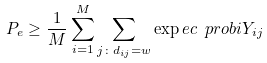Convert formula to latex. <formula><loc_0><loc_0><loc_500><loc_500>P _ { e } \geq \frac { 1 } { M } \sum _ { i = 1 } ^ { M } \sum _ { j \colon d _ { i j } = w } \exp e c { \ p r o b i { Y _ { i j } } }</formula> 